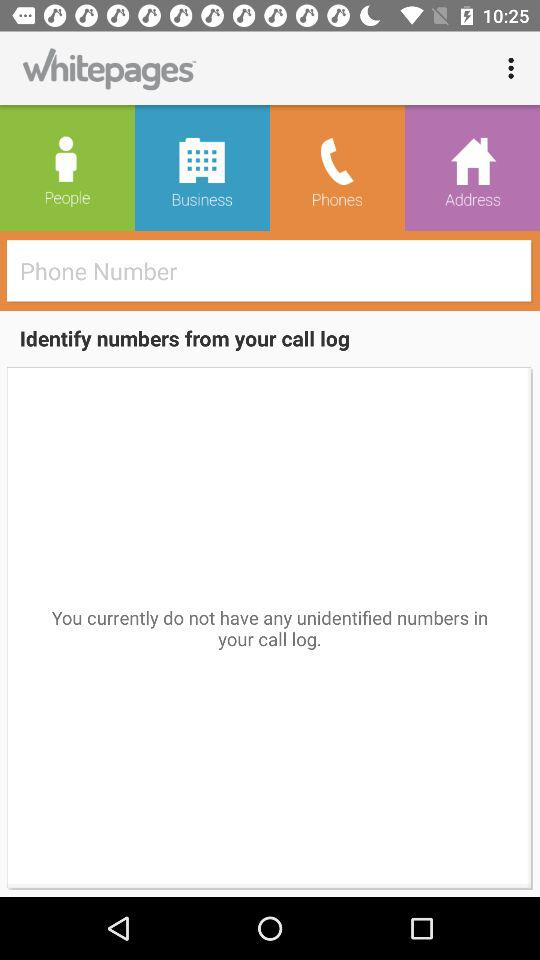What is the name of the application? The name of the application is "Whitepages". 